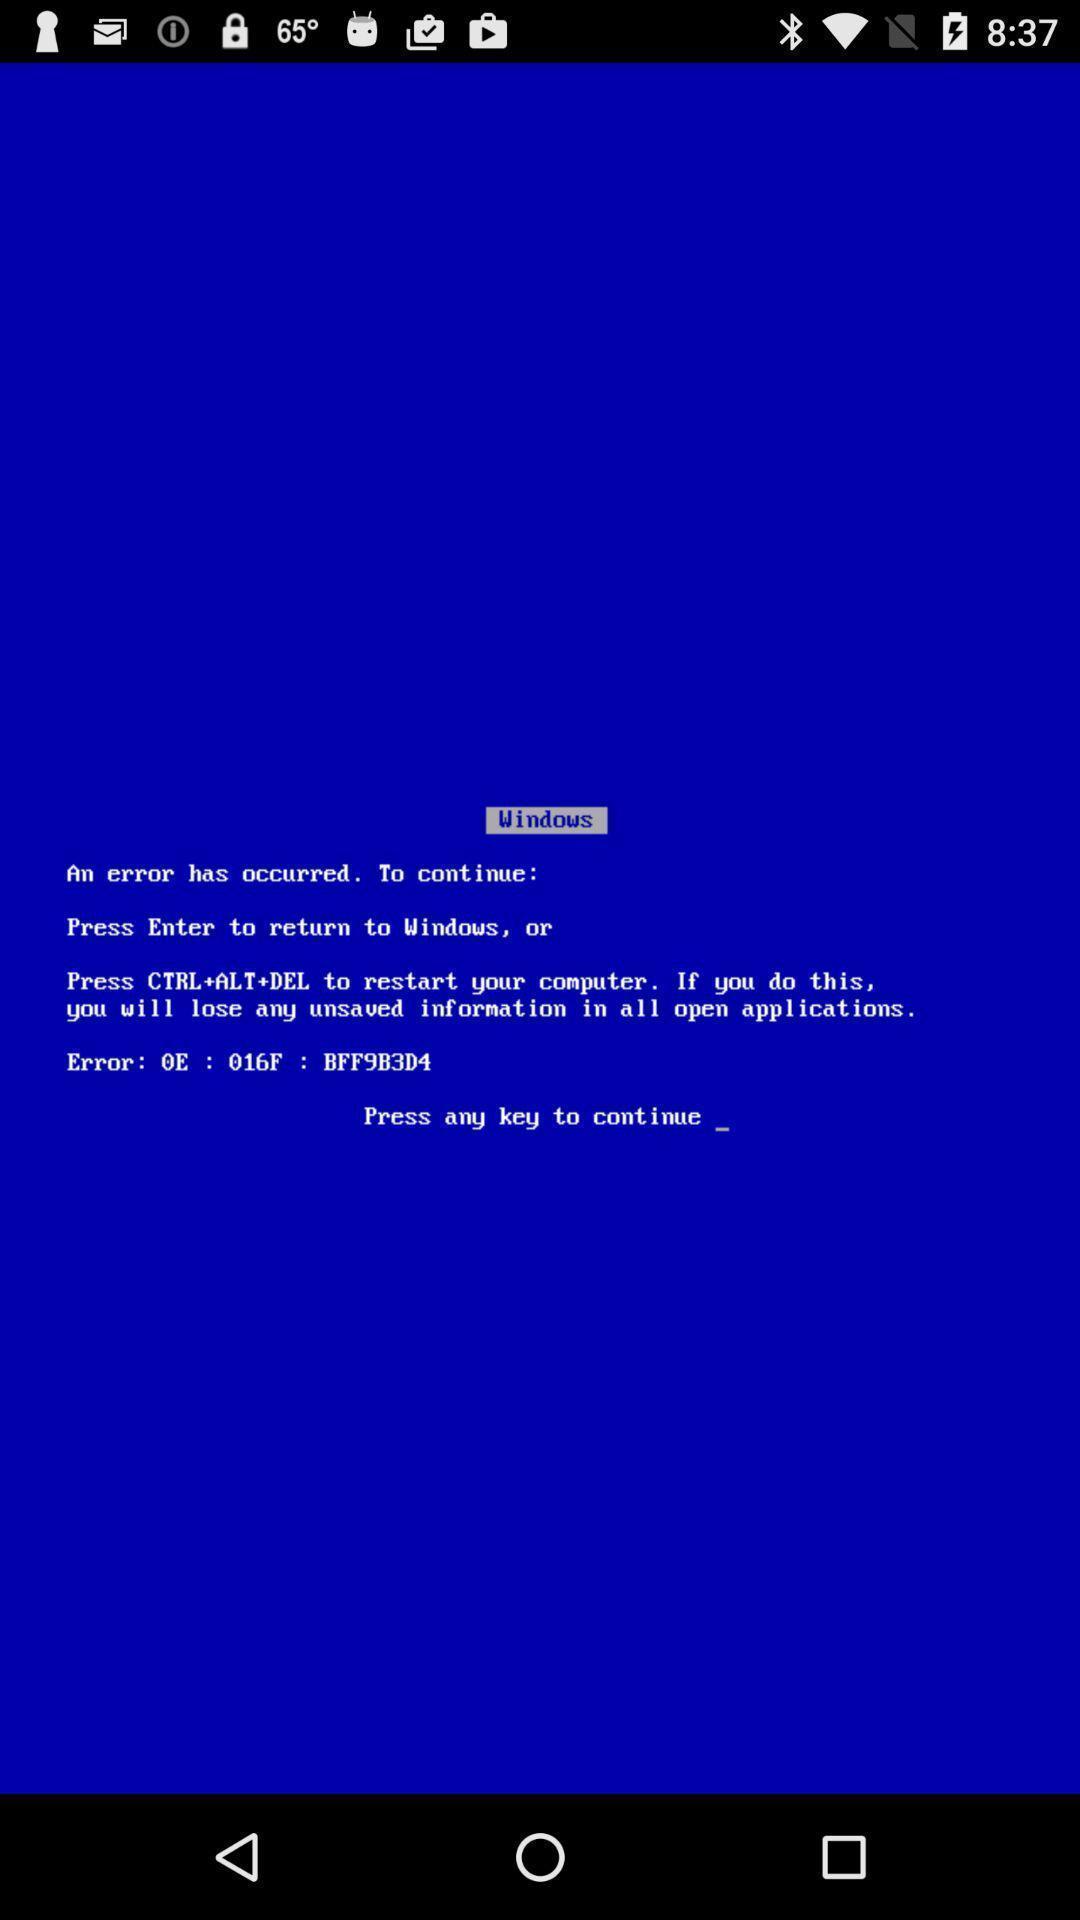Describe the key features of this screenshot. Screen shows error message in windows. 